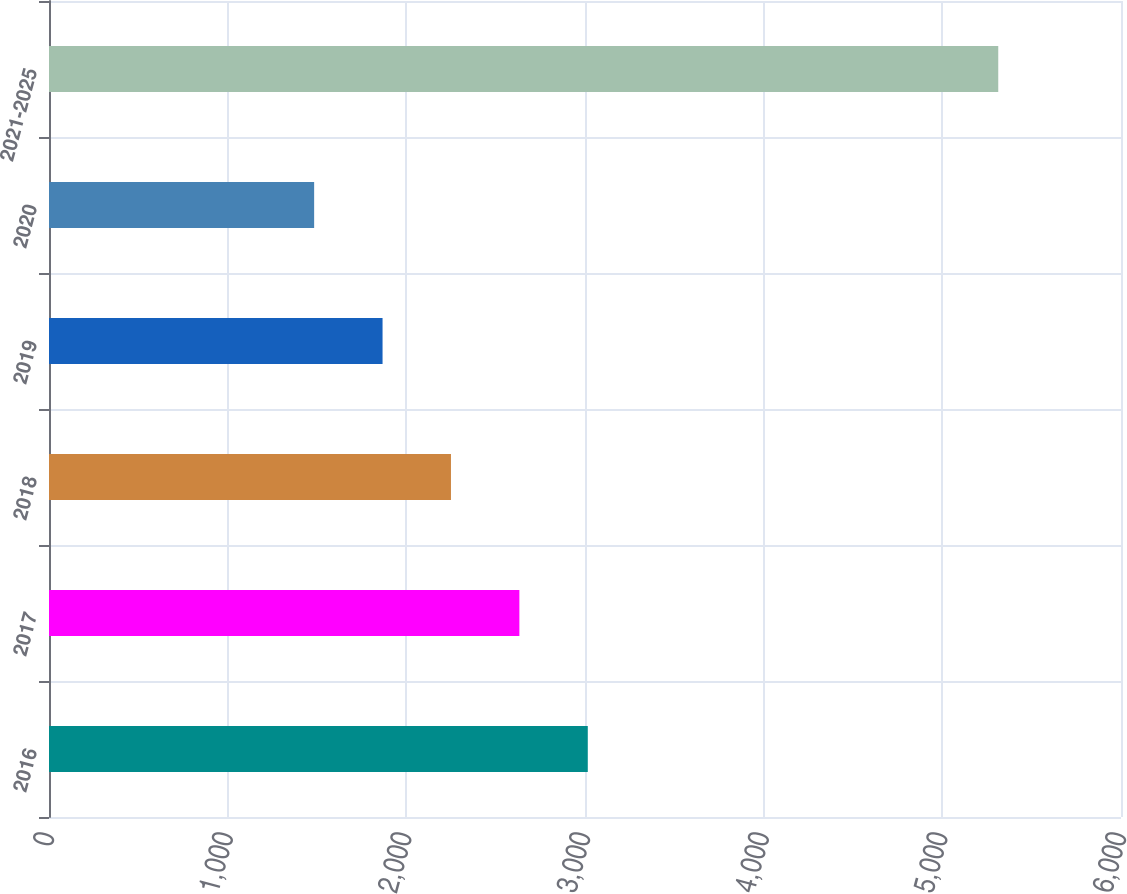Convert chart. <chart><loc_0><loc_0><loc_500><loc_500><bar_chart><fcel>2016<fcel>2017<fcel>2018<fcel>2019<fcel>2020<fcel>2021-2025<nl><fcel>3015.6<fcel>2632.7<fcel>2249.8<fcel>1866.9<fcel>1484<fcel>5313<nl></chart> 